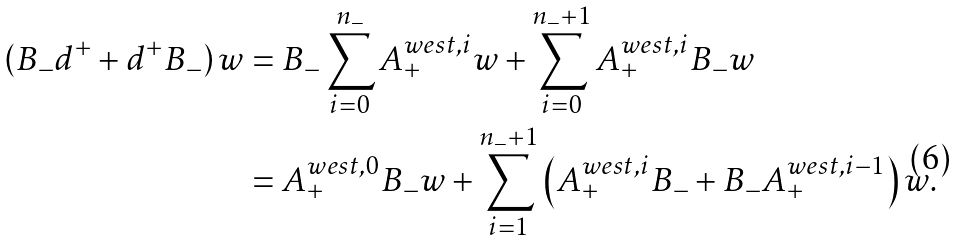Convert formula to latex. <formula><loc_0><loc_0><loc_500><loc_500>\left ( B _ { - } d ^ { + } + d ^ { + } B _ { - } \right ) w & = B _ { - } \sum _ { i = 0 } ^ { n _ { - } } A _ { + } ^ { w e s t , i } w + \sum _ { i = 0 } ^ { n _ { - } + 1 } A _ { + } ^ { w e s t , i } B _ { - } w \\ & = A _ { + } ^ { w e s t , 0 } B _ { - } w + \sum _ { i = 1 } ^ { n _ { - } + 1 } \left ( A _ { + } ^ { w e s t , i } B _ { - } + B _ { - } A _ { + } ^ { w e s t , i - 1 } \right ) w .</formula> 